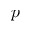Convert formula to latex. <formula><loc_0><loc_0><loc_500><loc_500>p</formula> 